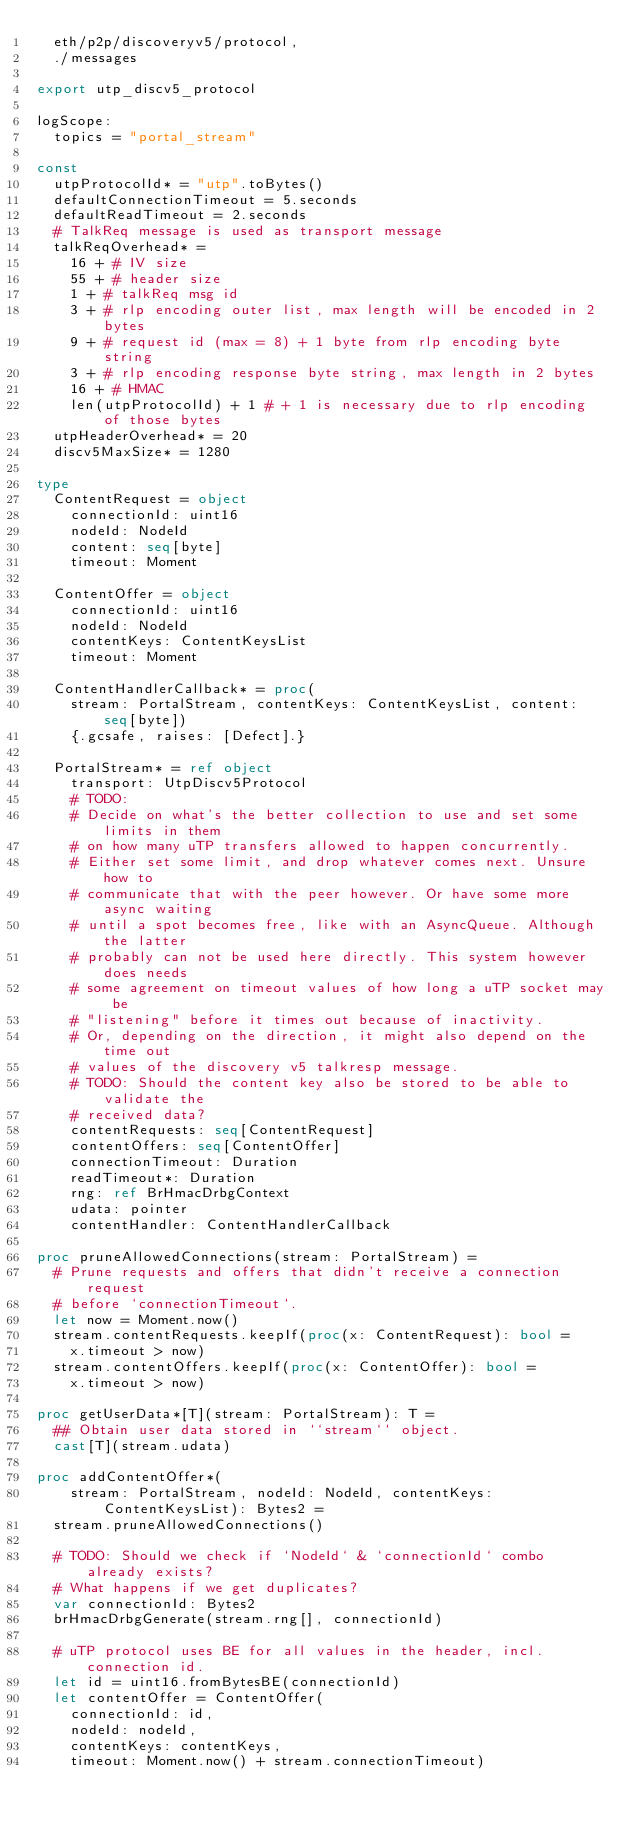<code> <loc_0><loc_0><loc_500><loc_500><_Nim_>  eth/p2p/discoveryv5/protocol,
  ./messages

export utp_discv5_protocol

logScope:
  topics = "portal_stream"

const
  utpProtocolId* = "utp".toBytes()
  defaultConnectionTimeout = 5.seconds
  defaultReadTimeout = 2.seconds
  # TalkReq message is used as transport message
  talkReqOverhead* =
    16 + # IV size
    55 + # header size
    1 + # talkReq msg id
    3 + # rlp encoding outer list, max length will be encoded in 2 bytes
    9 + # request id (max = 8) + 1 byte from rlp encoding byte string
    3 + # rlp encoding response byte string, max length in 2 bytes
    16 + # HMAC
    len(utpProtocolId) + 1 # + 1 is necessary due to rlp encoding of those bytes
  utpHeaderOverhead* = 20
  discv5MaxSize* = 1280

type
  ContentRequest = object
    connectionId: uint16
    nodeId: NodeId
    content: seq[byte]
    timeout: Moment

  ContentOffer = object
    connectionId: uint16
    nodeId: NodeId
    contentKeys: ContentKeysList
    timeout: Moment

  ContentHandlerCallback* = proc(
    stream: PortalStream, contentKeys: ContentKeysList, content: seq[byte])
    {.gcsafe, raises: [Defect].}

  PortalStream* = ref object
    transport: UtpDiscv5Protocol
    # TODO:
    # Decide on what's the better collection to use and set some limits in them
    # on how many uTP transfers allowed to happen concurrently.
    # Either set some limit, and drop whatever comes next. Unsure how to
    # communicate that with the peer however. Or have some more async waiting
    # until a spot becomes free, like with an AsyncQueue. Although the latter
    # probably can not be used here directly. This system however does needs
    # some agreement on timeout values of how long a uTP socket may be
    # "listening" before it times out because of inactivity.
    # Or, depending on the direction, it might also depend on the time out
    # values of the discovery v5 talkresp message.
    # TODO: Should the content key also be stored to be able to validate the
    # received data?
    contentRequests: seq[ContentRequest]
    contentOffers: seq[ContentOffer]
    connectionTimeout: Duration
    readTimeout*: Duration
    rng: ref BrHmacDrbgContext
    udata: pointer
    contentHandler: ContentHandlerCallback

proc pruneAllowedConnections(stream: PortalStream) =
  # Prune requests and offers that didn't receive a connection request
  # before `connectionTimeout`.
  let now = Moment.now()
  stream.contentRequests.keepIf(proc(x: ContentRequest): bool =
    x.timeout > now)
  stream.contentOffers.keepIf(proc(x: ContentOffer): bool =
    x.timeout > now)

proc getUserData*[T](stream: PortalStream): T =
  ## Obtain user data stored in ``stream`` object.
  cast[T](stream.udata)

proc addContentOffer*(
    stream: PortalStream, nodeId: NodeId, contentKeys: ContentKeysList): Bytes2 =
  stream.pruneAllowedConnections()

  # TODO: Should we check if `NodeId` & `connectionId` combo already exists?
  # What happens if we get duplicates?
  var connectionId: Bytes2
  brHmacDrbgGenerate(stream.rng[], connectionId)

  # uTP protocol uses BE for all values in the header, incl. connection id.
  let id = uint16.fromBytesBE(connectionId)
  let contentOffer = ContentOffer(
    connectionId: id,
    nodeId: nodeId,
    contentKeys: contentKeys,
    timeout: Moment.now() + stream.connectionTimeout)</code> 